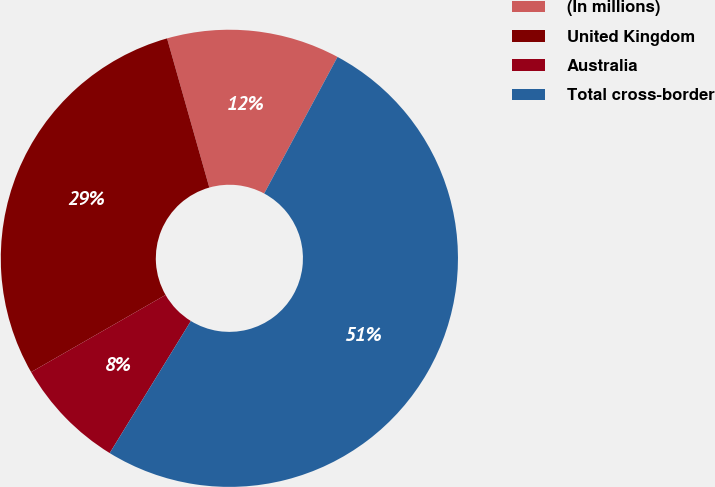Convert chart to OTSL. <chart><loc_0><loc_0><loc_500><loc_500><pie_chart><fcel>(In millions)<fcel>United Kingdom<fcel>Australia<fcel>Total cross-border<nl><fcel>12.24%<fcel>28.9%<fcel>7.94%<fcel>50.93%<nl></chart> 